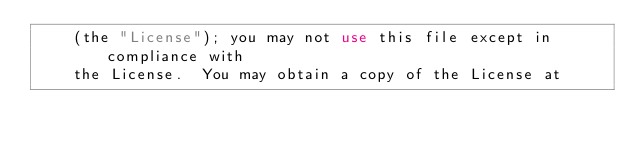<code> <loc_0><loc_0><loc_500><loc_500><_XML_>    (the "License"); you may not use this file except in compliance with
    the License.  You may obtain a copy of the License at
</code> 